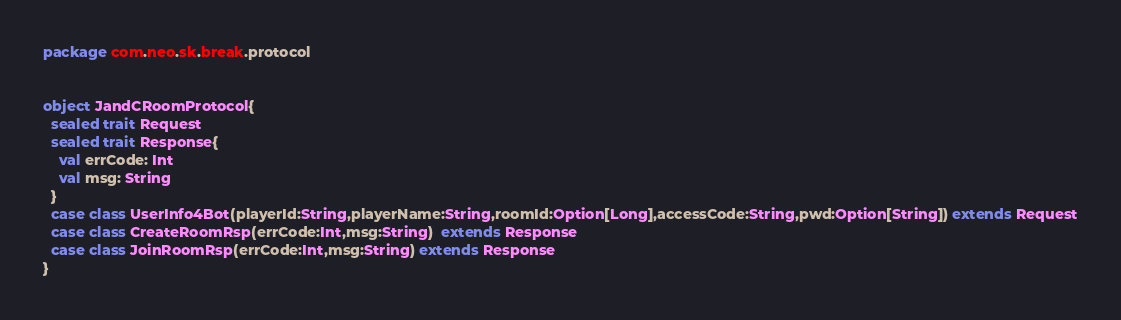<code> <loc_0><loc_0><loc_500><loc_500><_Scala_>package com.neo.sk.break.protocol


object JandCRoomProtocol{
  sealed trait Request
  sealed trait Response{
    val errCode: Int
    val msg: String
  }
  case class UserInfo4Bot(playerId:String,playerName:String,roomId:Option[Long],accessCode:String,pwd:Option[String]) extends Request
  case class CreateRoomRsp(errCode:Int,msg:String)  extends Response
  case class JoinRoomRsp(errCode:Int,msg:String) extends Response
}
</code> 